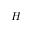Convert formula to latex. <formula><loc_0><loc_0><loc_500><loc_500>H</formula> 